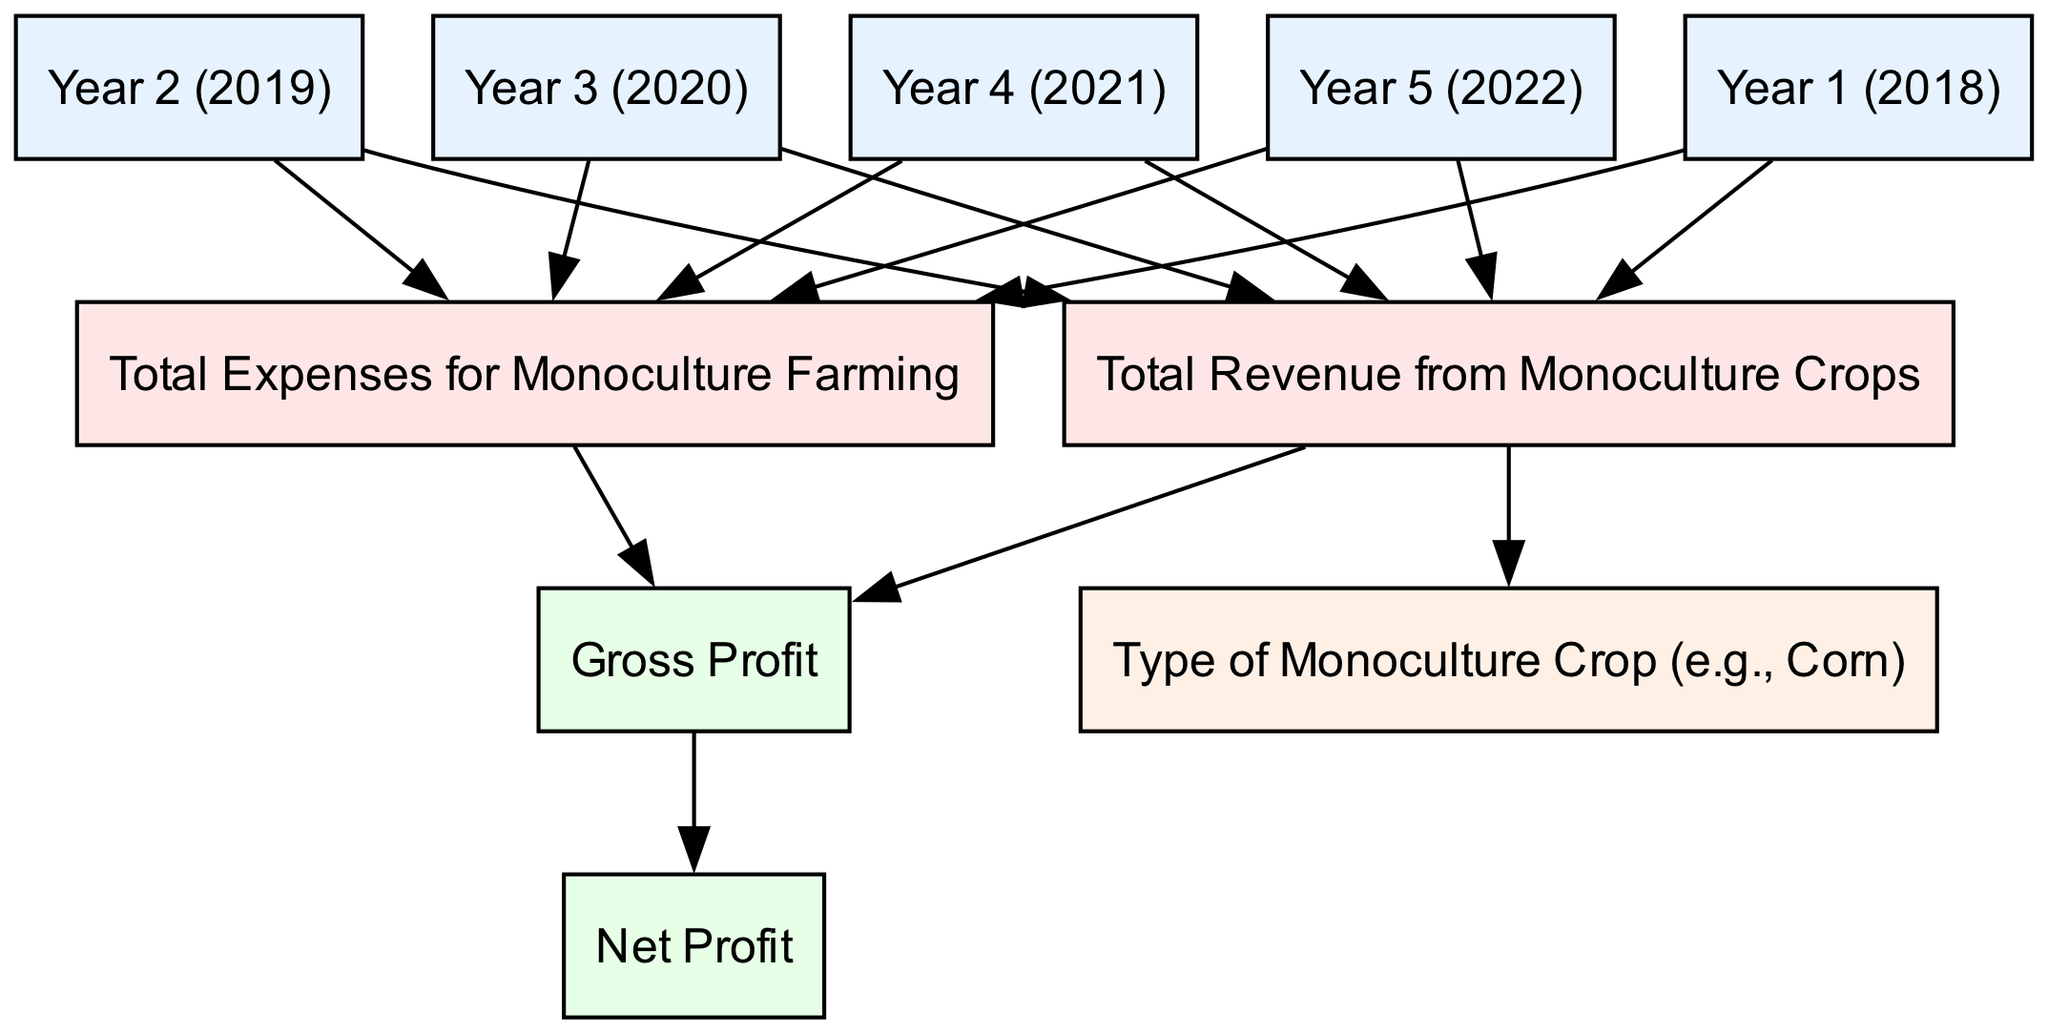What is the Total Revenue from Monoculture Crops in Year 1? The diagram shows a direct edge from Year 1 to the Revenue node, which provides the Total Revenue for that year. The specific value can be deduced visually from the diagram at the Revenue node connected to Year 1.
Answer: [insert value] What type of crop is represented in the diagram? The diagram contains an edge from the Revenue node to the Crop Type node, indicating that the Total Revenue is associated with specific types of monoculture crops. Therefore, the information about the crop type can be derived from the diagram closely tied to Revenue.
Answer: [insert crop type] How many years of data are represented in the diagram? There are five nodes labeled as Year 1 through Year 5, indicating that data for five separate years is displayed in the diagram. Thus, simply counting the Year nodes yields the answer to this question.
Answer: 5 What is the relationship between Gross Profit and Net Profit? The diagram illustrates a direct edge from Gross Profit to Net Profit, indicating that Net Profit is derived from or dependent on Gross Profit for its calculation. Thus, the relationship is that of dependency or flow from Gross Profit to Net Profit.
Answer: dependent Which year had expenses connecting to Revenue? Each year from Year 1 to Year 5 has a connection to both Revenue and Expenses in the diagram. Therefore, all five years have connections indicating expenses related to revenue. Since the question specifies any one year, any identified year is correct based on the diagram.
Answer: Year 1, Year 2, Year 3, Year 4, or Year 5 What is the flow of profit calculation starting from Revenue? The flow of profit calculation starts at Revenue, which connects to Gross Profit, and then Gross Profit connects to Net Profit. To elaborate, Gross Profit is calculated as Revenue minus Expenses, and then Net Profit is derived from Gross Profit. This flow indicates how Revenue impacts overall profitability.
Answer: Revenue to Gross Profit to Net Profit How many types of expenses are connected to Total Expenses? The diagram presents only one node labeled "Total Expenses," and it connects to various nodes indicating the relationship to different years but does not specify multiple types. Hence, there's only one Total Expenses node, indicating that only one type of total expenses representation exists visually in the diagram.
Answer: 1 What connections do the Year nodes have in terms of financial metrics? Each Year node connects to both the Revenue and Expenses nodes, indicating the financial metrics for each of the five years are captured similarly, allowing for comparison across years for Revenue and Expenses. Therefore, each of the Year nodes offers two connections representing its financial metrics.
Answer: Revenue and Expenses Which financial metrics are used to calculate Gross Profit? Gross Profit is calculated as the difference between Revenue and Expenses, as shown in the diagram where both Revenue and Expenses have direct edges pointing to Gross Profit. The illustration clearly depicts these two nodes working together to determine Gross Profit.
Answer: Revenue and Expenses 